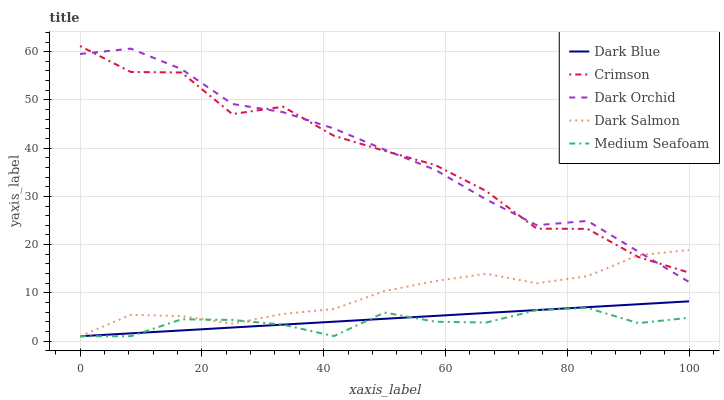Does Medium Seafoam have the minimum area under the curve?
Answer yes or no. Yes. Does Dark Orchid have the maximum area under the curve?
Answer yes or no. Yes. Does Dark Blue have the minimum area under the curve?
Answer yes or no. No. Does Dark Blue have the maximum area under the curve?
Answer yes or no. No. Is Dark Blue the smoothest?
Answer yes or no. Yes. Is Crimson the roughest?
Answer yes or no. Yes. Is Dark Salmon the smoothest?
Answer yes or no. No. Is Dark Salmon the roughest?
Answer yes or no. No. Does Dark Blue have the lowest value?
Answer yes or no. Yes. Does Dark Orchid have the lowest value?
Answer yes or no. No. Does Crimson have the highest value?
Answer yes or no. Yes. Does Dark Blue have the highest value?
Answer yes or no. No. Is Dark Blue less than Dark Orchid?
Answer yes or no. Yes. Is Dark Orchid greater than Medium Seafoam?
Answer yes or no. Yes. Does Dark Salmon intersect Dark Blue?
Answer yes or no. Yes. Is Dark Salmon less than Dark Blue?
Answer yes or no. No. Is Dark Salmon greater than Dark Blue?
Answer yes or no. No. Does Dark Blue intersect Dark Orchid?
Answer yes or no. No. 